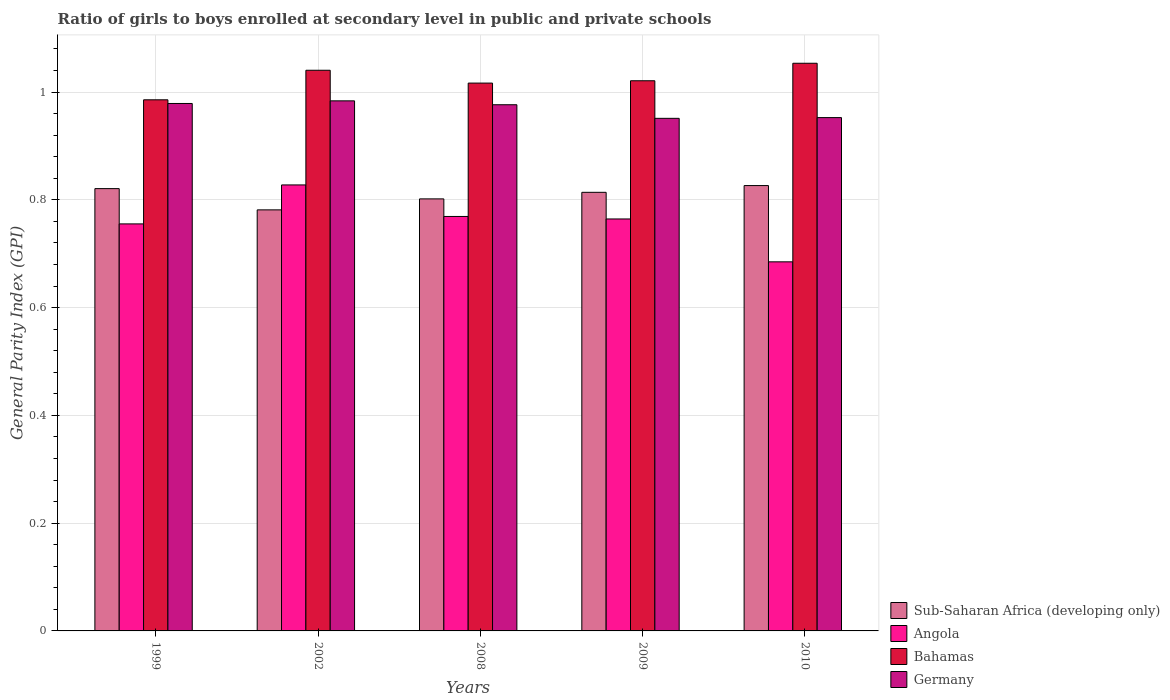Are the number of bars per tick equal to the number of legend labels?
Offer a terse response. Yes. Are the number of bars on each tick of the X-axis equal?
Your answer should be compact. Yes. How many bars are there on the 4th tick from the left?
Offer a very short reply. 4. In how many cases, is the number of bars for a given year not equal to the number of legend labels?
Provide a succinct answer. 0. What is the general parity index in Germany in 2002?
Offer a terse response. 0.98. Across all years, what is the maximum general parity index in Germany?
Your answer should be very brief. 0.98. Across all years, what is the minimum general parity index in Bahamas?
Give a very brief answer. 0.99. In which year was the general parity index in Bahamas maximum?
Your answer should be compact. 2010. In which year was the general parity index in Sub-Saharan Africa (developing only) minimum?
Give a very brief answer. 2002. What is the total general parity index in Sub-Saharan Africa (developing only) in the graph?
Provide a succinct answer. 4.04. What is the difference between the general parity index in Bahamas in 1999 and that in 2009?
Offer a terse response. -0.04. What is the difference between the general parity index in Angola in 2010 and the general parity index in Germany in 2002?
Give a very brief answer. -0.3. What is the average general parity index in Sub-Saharan Africa (developing only) per year?
Give a very brief answer. 0.81. In the year 2002, what is the difference between the general parity index in Bahamas and general parity index in Angola?
Your answer should be very brief. 0.21. What is the ratio of the general parity index in Germany in 1999 to that in 2008?
Give a very brief answer. 1. Is the general parity index in Sub-Saharan Africa (developing only) in 2002 less than that in 2009?
Your response must be concise. Yes. Is the difference between the general parity index in Bahamas in 1999 and 2002 greater than the difference between the general parity index in Angola in 1999 and 2002?
Your answer should be very brief. Yes. What is the difference between the highest and the second highest general parity index in Angola?
Offer a very short reply. 0.06. What is the difference between the highest and the lowest general parity index in Bahamas?
Offer a terse response. 0.07. In how many years, is the general parity index in Bahamas greater than the average general parity index in Bahamas taken over all years?
Make the answer very short. 2. Is the sum of the general parity index in Angola in 2008 and 2009 greater than the maximum general parity index in Sub-Saharan Africa (developing only) across all years?
Provide a short and direct response. Yes. What does the 1st bar from the left in 2002 represents?
Your answer should be very brief. Sub-Saharan Africa (developing only). What does the 2nd bar from the right in 2010 represents?
Provide a short and direct response. Bahamas. Is it the case that in every year, the sum of the general parity index in Bahamas and general parity index in Germany is greater than the general parity index in Sub-Saharan Africa (developing only)?
Give a very brief answer. Yes. How many bars are there?
Provide a succinct answer. 20. How many years are there in the graph?
Offer a very short reply. 5. What is the difference between two consecutive major ticks on the Y-axis?
Your answer should be compact. 0.2. Are the values on the major ticks of Y-axis written in scientific E-notation?
Your answer should be compact. No. Does the graph contain any zero values?
Offer a very short reply. No. Where does the legend appear in the graph?
Your answer should be compact. Bottom right. What is the title of the graph?
Provide a succinct answer. Ratio of girls to boys enrolled at secondary level in public and private schools. What is the label or title of the X-axis?
Ensure brevity in your answer.  Years. What is the label or title of the Y-axis?
Keep it short and to the point. General Parity Index (GPI). What is the General Parity Index (GPI) of Sub-Saharan Africa (developing only) in 1999?
Your response must be concise. 0.82. What is the General Parity Index (GPI) of Angola in 1999?
Keep it short and to the point. 0.76. What is the General Parity Index (GPI) in Bahamas in 1999?
Provide a succinct answer. 0.99. What is the General Parity Index (GPI) of Germany in 1999?
Give a very brief answer. 0.98. What is the General Parity Index (GPI) in Sub-Saharan Africa (developing only) in 2002?
Provide a short and direct response. 0.78. What is the General Parity Index (GPI) of Angola in 2002?
Your answer should be very brief. 0.83. What is the General Parity Index (GPI) of Bahamas in 2002?
Your answer should be very brief. 1.04. What is the General Parity Index (GPI) of Germany in 2002?
Offer a very short reply. 0.98. What is the General Parity Index (GPI) of Sub-Saharan Africa (developing only) in 2008?
Offer a terse response. 0.8. What is the General Parity Index (GPI) in Angola in 2008?
Provide a short and direct response. 0.77. What is the General Parity Index (GPI) in Bahamas in 2008?
Make the answer very short. 1.02. What is the General Parity Index (GPI) in Germany in 2008?
Provide a succinct answer. 0.98. What is the General Parity Index (GPI) in Sub-Saharan Africa (developing only) in 2009?
Provide a succinct answer. 0.81. What is the General Parity Index (GPI) of Angola in 2009?
Ensure brevity in your answer.  0.76. What is the General Parity Index (GPI) of Bahamas in 2009?
Make the answer very short. 1.02. What is the General Parity Index (GPI) in Germany in 2009?
Your answer should be very brief. 0.95. What is the General Parity Index (GPI) of Sub-Saharan Africa (developing only) in 2010?
Your response must be concise. 0.83. What is the General Parity Index (GPI) in Angola in 2010?
Offer a very short reply. 0.68. What is the General Parity Index (GPI) of Bahamas in 2010?
Offer a terse response. 1.05. What is the General Parity Index (GPI) in Germany in 2010?
Your response must be concise. 0.95. Across all years, what is the maximum General Parity Index (GPI) in Sub-Saharan Africa (developing only)?
Provide a succinct answer. 0.83. Across all years, what is the maximum General Parity Index (GPI) of Angola?
Your response must be concise. 0.83. Across all years, what is the maximum General Parity Index (GPI) of Bahamas?
Offer a terse response. 1.05. Across all years, what is the maximum General Parity Index (GPI) of Germany?
Make the answer very short. 0.98. Across all years, what is the minimum General Parity Index (GPI) of Sub-Saharan Africa (developing only)?
Offer a very short reply. 0.78. Across all years, what is the minimum General Parity Index (GPI) of Angola?
Make the answer very short. 0.68. Across all years, what is the minimum General Parity Index (GPI) in Bahamas?
Your response must be concise. 0.99. Across all years, what is the minimum General Parity Index (GPI) in Germany?
Keep it short and to the point. 0.95. What is the total General Parity Index (GPI) of Sub-Saharan Africa (developing only) in the graph?
Give a very brief answer. 4.04. What is the total General Parity Index (GPI) of Angola in the graph?
Offer a terse response. 3.8. What is the total General Parity Index (GPI) of Bahamas in the graph?
Keep it short and to the point. 5.12. What is the total General Parity Index (GPI) in Germany in the graph?
Make the answer very short. 4.84. What is the difference between the General Parity Index (GPI) of Sub-Saharan Africa (developing only) in 1999 and that in 2002?
Provide a short and direct response. 0.04. What is the difference between the General Parity Index (GPI) of Angola in 1999 and that in 2002?
Your response must be concise. -0.07. What is the difference between the General Parity Index (GPI) in Bahamas in 1999 and that in 2002?
Your answer should be compact. -0.05. What is the difference between the General Parity Index (GPI) in Germany in 1999 and that in 2002?
Ensure brevity in your answer.  -0. What is the difference between the General Parity Index (GPI) of Sub-Saharan Africa (developing only) in 1999 and that in 2008?
Give a very brief answer. 0.02. What is the difference between the General Parity Index (GPI) of Angola in 1999 and that in 2008?
Make the answer very short. -0.01. What is the difference between the General Parity Index (GPI) of Bahamas in 1999 and that in 2008?
Provide a short and direct response. -0.03. What is the difference between the General Parity Index (GPI) of Germany in 1999 and that in 2008?
Provide a short and direct response. 0. What is the difference between the General Parity Index (GPI) in Sub-Saharan Africa (developing only) in 1999 and that in 2009?
Provide a short and direct response. 0.01. What is the difference between the General Parity Index (GPI) in Angola in 1999 and that in 2009?
Keep it short and to the point. -0.01. What is the difference between the General Parity Index (GPI) in Bahamas in 1999 and that in 2009?
Ensure brevity in your answer.  -0.04. What is the difference between the General Parity Index (GPI) in Germany in 1999 and that in 2009?
Your answer should be compact. 0.03. What is the difference between the General Parity Index (GPI) of Sub-Saharan Africa (developing only) in 1999 and that in 2010?
Give a very brief answer. -0.01. What is the difference between the General Parity Index (GPI) of Angola in 1999 and that in 2010?
Offer a very short reply. 0.07. What is the difference between the General Parity Index (GPI) in Bahamas in 1999 and that in 2010?
Provide a short and direct response. -0.07. What is the difference between the General Parity Index (GPI) of Germany in 1999 and that in 2010?
Provide a short and direct response. 0.03. What is the difference between the General Parity Index (GPI) in Sub-Saharan Africa (developing only) in 2002 and that in 2008?
Offer a very short reply. -0.02. What is the difference between the General Parity Index (GPI) of Angola in 2002 and that in 2008?
Your answer should be very brief. 0.06. What is the difference between the General Parity Index (GPI) in Bahamas in 2002 and that in 2008?
Offer a terse response. 0.02. What is the difference between the General Parity Index (GPI) of Germany in 2002 and that in 2008?
Your response must be concise. 0.01. What is the difference between the General Parity Index (GPI) in Sub-Saharan Africa (developing only) in 2002 and that in 2009?
Ensure brevity in your answer.  -0.03. What is the difference between the General Parity Index (GPI) in Angola in 2002 and that in 2009?
Make the answer very short. 0.06. What is the difference between the General Parity Index (GPI) in Bahamas in 2002 and that in 2009?
Your answer should be very brief. 0.02. What is the difference between the General Parity Index (GPI) in Germany in 2002 and that in 2009?
Ensure brevity in your answer.  0.03. What is the difference between the General Parity Index (GPI) of Sub-Saharan Africa (developing only) in 2002 and that in 2010?
Your answer should be very brief. -0.05. What is the difference between the General Parity Index (GPI) of Angola in 2002 and that in 2010?
Offer a very short reply. 0.14. What is the difference between the General Parity Index (GPI) of Bahamas in 2002 and that in 2010?
Give a very brief answer. -0.01. What is the difference between the General Parity Index (GPI) in Germany in 2002 and that in 2010?
Your answer should be compact. 0.03. What is the difference between the General Parity Index (GPI) in Sub-Saharan Africa (developing only) in 2008 and that in 2009?
Make the answer very short. -0.01. What is the difference between the General Parity Index (GPI) of Angola in 2008 and that in 2009?
Your answer should be very brief. 0. What is the difference between the General Parity Index (GPI) in Bahamas in 2008 and that in 2009?
Your answer should be very brief. -0. What is the difference between the General Parity Index (GPI) of Germany in 2008 and that in 2009?
Keep it short and to the point. 0.03. What is the difference between the General Parity Index (GPI) of Sub-Saharan Africa (developing only) in 2008 and that in 2010?
Your answer should be very brief. -0.02. What is the difference between the General Parity Index (GPI) of Angola in 2008 and that in 2010?
Provide a succinct answer. 0.08. What is the difference between the General Parity Index (GPI) of Bahamas in 2008 and that in 2010?
Provide a short and direct response. -0.04. What is the difference between the General Parity Index (GPI) in Germany in 2008 and that in 2010?
Provide a short and direct response. 0.02. What is the difference between the General Parity Index (GPI) of Sub-Saharan Africa (developing only) in 2009 and that in 2010?
Give a very brief answer. -0.01. What is the difference between the General Parity Index (GPI) of Angola in 2009 and that in 2010?
Keep it short and to the point. 0.08. What is the difference between the General Parity Index (GPI) of Bahamas in 2009 and that in 2010?
Your answer should be very brief. -0.03. What is the difference between the General Parity Index (GPI) of Germany in 2009 and that in 2010?
Keep it short and to the point. -0. What is the difference between the General Parity Index (GPI) in Sub-Saharan Africa (developing only) in 1999 and the General Parity Index (GPI) in Angola in 2002?
Your answer should be very brief. -0.01. What is the difference between the General Parity Index (GPI) in Sub-Saharan Africa (developing only) in 1999 and the General Parity Index (GPI) in Bahamas in 2002?
Your response must be concise. -0.22. What is the difference between the General Parity Index (GPI) of Sub-Saharan Africa (developing only) in 1999 and the General Parity Index (GPI) of Germany in 2002?
Provide a short and direct response. -0.16. What is the difference between the General Parity Index (GPI) in Angola in 1999 and the General Parity Index (GPI) in Bahamas in 2002?
Give a very brief answer. -0.29. What is the difference between the General Parity Index (GPI) of Angola in 1999 and the General Parity Index (GPI) of Germany in 2002?
Give a very brief answer. -0.23. What is the difference between the General Parity Index (GPI) of Bahamas in 1999 and the General Parity Index (GPI) of Germany in 2002?
Provide a short and direct response. 0. What is the difference between the General Parity Index (GPI) in Sub-Saharan Africa (developing only) in 1999 and the General Parity Index (GPI) in Angola in 2008?
Give a very brief answer. 0.05. What is the difference between the General Parity Index (GPI) in Sub-Saharan Africa (developing only) in 1999 and the General Parity Index (GPI) in Bahamas in 2008?
Provide a short and direct response. -0.2. What is the difference between the General Parity Index (GPI) in Sub-Saharan Africa (developing only) in 1999 and the General Parity Index (GPI) in Germany in 2008?
Your answer should be compact. -0.16. What is the difference between the General Parity Index (GPI) in Angola in 1999 and the General Parity Index (GPI) in Bahamas in 2008?
Ensure brevity in your answer.  -0.26. What is the difference between the General Parity Index (GPI) in Angola in 1999 and the General Parity Index (GPI) in Germany in 2008?
Keep it short and to the point. -0.22. What is the difference between the General Parity Index (GPI) in Bahamas in 1999 and the General Parity Index (GPI) in Germany in 2008?
Offer a terse response. 0.01. What is the difference between the General Parity Index (GPI) in Sub-Saharan Africa (developing only) in 1999 and the General Parity Index (GPI) in Angola in 2009?
Ensure brevity in your answer.  0.06. What is the difference between the General Parity Index (GPI) of Sub-Saharan Africa (developing only) in 1999 and the General Parity Index (GPI) of Bahamas in 2009?
Give a very brief answer. -0.2. What is the difference between the General Parity Index (GPI) of Sub-Saharan Africa (developing only) in 1999 and the General Parity Index (GPI) of Germany in 2009?
Offer a very short reply. -0.13. What is the difference between the General Parity Index (GPI) of Angola in 1999 and the General Parity Index (GPI) of Bahamas in 2009?
Your response must be concise. -0.27. What is the difference between the General Parity Index (GPI) in Angola in 1999 and the General Parity Index (GPI) in Germany in 2009?
Keep it short and to the point. -0.2. What is the difference between the General Parity Index (GPI) in Bahamas in 1999 and the General Parity Index (GPI) in Germany in 2009?
Give a very brief answer. 0.03. What is the difference between the General Parity Index (GPI) in Sub-Saharan Africa (developing only) in 1999 and the General Parity Index (GPI) in Angola in 2010?
Make the answer very short. 0.14. What is the difference between the General Parity Index (GPI) of Sub-Saharan Africa (developing only) in 1999 and the General Parity Index (GPI) of Bahamas in 2010?
Offer a very short reply. -0.23. What is the difference between the General Parity Index (GPI) in Sub-Saharan Africa (developing only) in 1999 and the General Parity Index (GPI) in Germany in 2010?
Give a very brief answer. -0.13. What is the difference between the General Parity Index (GPI) of Angola in 1999 and the General Parity Index (GPI) of Bahamas in 2010?
Your answer should be very brief. -0.3. What is the difference between the General Parity Index (GPI) of Angola in 1999 and the General Parity Index (GPI) of Germany in 2010?
Provide a succinct answer. -0.2. What is the difference between the General Parity Index (GPI) of Bahamas in 1999 and the General Parity Index (GPI) of Germany in 2010?
Ensure brevity in your answer.  0.03. What is the difference between the General Parity Index (GPI) of Sub-Saharan Africa (developing only) in 2002 and the General Parity Index (GPI) of Angola in 2008?
Ensure brevity in your answer.  0.01. What is the difference between the General Parity Index (GPI) of Sub-Saharan Africa (developing only) in 2002 and the General Parity Index (GPI) of Bahamas in 2008?
Give a very brief answer. -0.24. What is the difference between the General Parity Index (GPI) in Sub-Saharan Africa (developing only) in 2002 and the General Parity Index (GPI) in Germany in 2008?
Give a very brief answer. -0.2. What is the difference between the General Parity Index (GPI) of Angola in 2002 and the General Parity Index (GPI) of Bahamas in 2008?
Provide a short and direct response. -0.19. What is the difference between the General Parity Index (GPI) of Angola in 2002 and the General Parity Index (GPI) of Germany in 2008?
Your answer should be very brief. -0.15. What is the difference between the General Parity Index (GPI) in Bahamas in 2002 and the General Parity Index (GPI) in Germany in 2008?
Give a very brief answer. 0.06. What is the difference between the General Parity Index (GPI) in Sub-Saharan Africa (developing only) in 2002 and the General Parity Index (GPI) in Angola in 2009?
Your answer should be compact. 0.02. What is the difference between the General Parity Index (GPI) in Sub-Saharan Africa (developing only) in 2002 and the General Parity Index (GPI) in Bahamas in 2009?
Make the answer very short. -0.24. What is the difference between the General Parity Index (GPI) in Sub-Saharan Africa (developing only) in 2002 and the General Parity Index (GPI) in Germany in 2009?
Keep it short and to the point. -0.17. What is the difference between the General Parity Index (GPI) in Angola in 2002 and the General Parity Index (GPI) in Bahamas in 2009?
Your response must be concise. -0.19. What is the difference between the General Parity Index (GPI) in Angola in 2002 and the General Parity Index (GPI) in Germany in 2009?
Offer a terse response. -0.12. What is the difference between the General Parity Index (GPI) in Bahamas in 2002 and the General Parity Index (GPI) in Germany in 2009?
Give a very brief answer. 0.09. What is the difference between the General Parity Index (GPI) in Sub-Saharan Africa (developing only) in 2002 and the General Parity Index (GPI) in Angola in 2010?
Offer a very short reply. 0.1. What is the difference between the General Parity Index (GPI) of Sub-Saharan Africa (developing only) in 2002 and the General Parity Index (GPI) of Bahamas in 2010?
Offer a terse response. -0.27. What is the difference between the General Parity Index (GPI) of Sub-Saharan Africa (developing only) in 2002 and the General Parity Index (GPI) of Germany in 2010?
Make the answer very short. -0.17. What is the difference between the General Parity Index (GPI) in Angola in 2002 and the General Parity Index (GPI) in Bahamas in 2010?
Ensure brevity in your answer.  -0.23. What is the difference between the General Parity Index (GPI) in Angola in 2002 and the General Parity Index (GPI) in Germany in 2010?
Keep it short and to the point. -0.12. What is the difference between the General Parity Index (GPI) in Bahamas in 2002 and the General Parity Index (GPI) in Germany in 2010?
Your answer should be very brief. 0.09. What is the difference between the General Parity Index (GPI) of Sub-Saharan Africa (developing only) in 2008 and the General Parity Index (GPI) of Angola in 2009?
Offer a terse response. 0.04. What is the difference between the General Parity Index (GPI) of Sub-Saharan Africa (developing only) in 2008 and the General Parity Index (GPI) of Bahamas in 2009?
Provide a short and direct response. -0.22. What is the difference between the General Parity Index (GPI) of Sub-Saharan Africa (developing only) in 2008 and the General Parity Index (GPI) of Germany in 2009?
Your answer should be very brief. -0.15. What is the difference between the General Parity Index (GPI) of Angola in 2008 and the General Parity Index (GPI) of Bahamas in 2009?
Give a very brief answer. -0.25. What is the difference between the General Parity Index (GPI) of Angola in 2008 and the General Parity Index (GPI) of Germany in 2009?
Your answer should be very brief. -0.18. What is the difference between the General Parity Index (GPI) of Bahamas in 2008 and the General Parity Index (GPI) of Germany in 2009?
Your response must be concise. 0.07. What is the difference between the General Parity Index (GPI) of Sub-Saharan Africa (developing only) in 2008 and the General Parity Index (GPI) of Angola in 2010?
Ensure brevity in your answer.  0.12. What is the difference between the General Parity Index (GPI) of Sub-Saharan Africa (developing only) in 2008 and the General Parity Index (GPI) of Bahamas in 2010?
Your response must be concise. -0.25. What is the difference between the General Parity Index (GPI) in Sub-Saharan Africa (developing only) in 2008 and the General Parity Index (GPI) in Germany in 2010?
Offer a terse response. -0.15. What is the difference between the General Parity Index (GPI) of Angola in 2008 and the General Parity Index (GPI) of Bahamas in 2010?
Your answer should be compact. -0.28. What is the difference between the General Parity Index (GPI) of Angola in 2008 and the General Parity Index (GPI) of Germany in 2010?
Offer a very short reply. -0.18. What is the difference between the General Parity Index (GPI) in Bahamas in 2008 and the General Parity Index (GPI) in Germany in 2010?
Provide a short and direct response. 0.06. What is the difference between the General Parity Index (GPI) of Sub-Saharan Africa (developing only) in 2009 and the General Parity Index (GPI) of Angola in 2010?
Your answer should be compact. 0.13. What is the difference between the General Parity Index (GPI) in Sub-Saharan Africa (developing only) in 2009 and the General Parity Index (GPI) in Bahamas in 2010?
Make the answer very short. -0.24. What is the difference between the General Parity Index (GPI) of Sub-Saharan Africa (developing only) in 2009 and the General Parity Index (GPI) of Germany in 2010?
Your response must be concise. -0.14. What is the difference between the General Parity Index (GPI) of Angola in 2009 and the General Parity Index (GPI) of Bahamas in 2010?
Provide a succinct answer. -0.29. What is the difference between the General Parity Index (GPI) in Angola in 2009 and the General Parity Index (GPI) in Germany in 2010?
Your answer should be compact. -0.19. What is the difference between the General Parity Index (GPI) in Bahamas in 2009 and the General Parity Index (GPI) in Germany in 2010?
Your response must be concise. 0.07. What is the average General Parity Index (GPI) in Sub-Saharan Africa (developing only) per year?
Give a very brief answer. 0.81. What is the average General Parity Index (GPI) in Angola per year?
Offer a terse response. 0.76. What is the average General Parity Index (GPI) of Bahamas per year?
Offer a terse response. 1.02. What is the average General Parity Index (GPI) of Germany per year?
Offer a terse response. 0.97. In the year 1999, what is the difference between the General Parity Index (GPI) of Sub-Saharan Africa (developing only) and General Parity Index (GPI) of Angola?
Provide a succinct answer. 0.07. In the year 1999, what is the difference between the General Parity Index (GPI) of Sub-Saharan Africa (developing only) and General Parity Index (GPI) of Bahamas?
Give a very brief answer. -0.16. In the year 1999, what is the difference between the General Parity Index (GPI) in Sub-Saharan Africa (developing only) and General Parity Index (GPI) in Germany?
Your response must be concise. -0.16. In the year 1999, what is the difference between the General Parity Index (GPI) in Angola and General Parity Index (GPI) in Bahamas?
Provide a short and direct response. -0.23. In the year 1999, what is the difference between the General Parity Index (GPI) of Angola and General Parity Index (GPI) of Germany?
Offer a terse response. -0.22. In the year 1999, what is the difference between the General Parity Index (GPI) of Bahamas and General Parity Index (GPI) of Germany?
Your answer should be compact. 0.01. In the year 2002, what is the difference between the General Parity Index (GPI) in Sub-Saharan Africa (developing only) and General Parity Index (GPI) in Angola?
Make the answer very short. -0.05. In the year 2002, what is the difference between the General Parity Index (GPI) of Sub-Saharan Africa (developing only) and General Parity Index (GPI) of Bahamas?
Your answer should be very brief. -0.26. In the year 2002, what is the difference between the General Parity Index (GPI) of Sub-Saharan Africa (developing only) and General Parity Index (GPI) of Germany?
Ensure brevity in your answer.  -0.2. In the year 2002, what is the difference between the General Parity Index (GPI) in Angola and General Parity Index (GPI) in Bahamas?
Your answer should be compact. -0.21. In the year 2002, what is the difference between the General Parity Index (GPI) of Angola and General Parity Index (GPI) of Germany?
Provide a short and direct response. -0.16. In the year 2002, what is the difference between the General Parity Index (GPI) of Bahamas and General Parity Index (GPI) of Germany?
Provide a short and direct response. 0.06. In the year 2008, what is the difference between the General Parity Index (GPI) of Sub-Saharan Africa (developing only) and General Parity Index (GPI) of Angola?
Provide a succinct answer. 0.03. In the year 2008, what is the difference between the General Parity Index (GPI) of Sub-Saharan Africa (developing only) and General Parity Index (GPI) of Bahamas?
Give a very brief answer. -0.21. In the year 2008, what is the difference between the General Parity Index (GPI) in Sub-Saharan Africa (developing only) and General Parity Index (GPI) in Germany?
Provide a short and direct response. -0.17. In the year 2008, what is the difference between the General Parity Index (GPI) in Angola and General Parity Index (GPI) in Bahamas?
Give a very brief answer. -0.25. In the year 2008, what is the difference between the General Parity Index (GPI) of Angola and General Parity Index (GPI) of Germany?
Offer a terse response. -0.21. In the year 2008, what is the difference between the General Parity Index (GPI) in Bahamas and General Parity Index (GPI) in Germany?
Your response must be concise. 0.04. In the year 2009, what is the difference between the General Parity Index (GPI) in Sub-Saharan Africa (developing only) and General Parity Index (GPI) in Angola?
Give a very brief answer. 0.05. In the year 2009, what is the difference between the General Parity Index (GPI) of Sub-Saharan Africa (developing only) and General Parity Index (GPI) of Bahamas?
Provide a short and direct response. -0.21. In the year 2009, what is the difference between the General Parity Index (GPI) of Sub-Saharan Africa (developing only) and General Parity Index (GPI) of Germany?
Offer a very short reply. -0.14. In the year 2009, what is the difference between the General Parity Index (GPI) of Angola and General Parity Index (GPI) of Bahamas?
Make the answer very short. -0.26. In the year 2009, what is the difference between the General Parity Index (GPI) in Angola and General Parity Index (GPI) in Germany?
Your answer should be compact. -0.19. In the year 2009, what is the difference between the General Parity Index (GPI) of Bahamas and General Parity Index (GPI) of Germany?
Your answer should be compact. 0.07. In the year 2010, what is the difference between the General Parity Index (GPI) of Sub-Saharan Africa (developing only) and General Parity Index (GPI) of Angola?
Provide a short and direct response. 0.14. In the year 2010, what is the difference between the General Parity Index (GPI) in Sub-Saharan Africa (developing only) and General Parity Index (GPI) in Bahamas?
Your response must be concise. -0.23. In the year 2010, what is the difference between the General Parity Index (GPI) of Sub-Saharan Africa (developing only) and General Parity Index (GPI) of Germany?
Provide a short and direct response. -0.13. In the year 2010, what is the difference between the General Parity Index (GPI) of Angola and General Parity Index (GPI) of Bahamas?
Provide a short and direct response. -0.37. In the year 2010, what is the difference between the General Parity Index (GPI) of Angola and General Parity Index (GPI) of Germany?
Ensure brevity in your answer.  -0.27. In the year 2010, what is the difference between the General Parity Index (GPI) of Bahamas and General Parity Index (GPI) of Germany?
Provide a short and direct response. 0.1. What is the ratio of the General Parity Index (GPI) of Sub-Saharan Africa (developing only) in 1999 to that in 2002?
Keep it short and to the point. 1.05. What is the ratio of the General Parity Index (GPI) of Angola in 1999 to that in 2002?
Keep it short and to the point. 0.91. What is the ratio of the General Parity Index (GPI) of Bahamas in 1999 to that in 2002?
Give a very brief answer. 0.95. What is the ratio of the General Parity Index (GPI) of Germany in 1999 to that in 2002?
Offer a very short reply. 1. What is the ratio of the General Parity Index (GPI) in Sub-Saharan Africa (developing only) in 1999 to that in 2008?
Your answer should be very brief. 1.02. What is the ratio of the General Parity Index (GPI) of Bahamas in 1999 to that in 2008?
Your answer should be compact. 0.97. What is the ratio of the General Parity Index (GPI) of Sub-Saharan Africa (developing only) in 1999 to that in 2009?
Provide a short and direct response. 1.01. What is the ratio of the General Parity Index (GPI) of Angola in 1999 to that in 2009?
Your answer should be very brief. 0.99. What is the ratio of the General Parity Index (GPI) of Bahamas in 1999 to that in 2009?
Offer a very short reply. 0.97. What is the ratio of the General Parity Index (GPI) of Germany in 1999 to that in 2009?
Your answer should be compact. 1.03. What is the ratio of the General Parity Index (GPI) of Angola in 1999 to that in 2010?
Keep it short and to the point. 1.1. What is the ratio of the General Parity Index (GPI) in Bahamas in 1999 to that in 2010?
Offer a terse response. 0.94. What is the ratio of the General Parity Index (GPI) of Germany in 1999 to that in 2010?
Give a very brief answer. 1.03. What is the ratio of the General Parity Index (GPI) of Sub-Saharan Africa (developing only) in 2002 to that in 2008?
Your answer should be compact. 0.97. What is the ratio of the General Parity Index (GPI) in Angola in 2002 to that in 2008?
Offer a very short reply. 1.08. What is the ratio of the General Parity Index (GPI) of Bahamas in 2002 to that in 2008?
Keep it short and to the point. 1.02. What is the ratio of the General Parity Index (GPI) in Germany in 2002 to that in 2008?
Ensure brevity in your answer.  1.01. What is the ratio of the General Parity Index (GPI) in Sub-Saharan Africa (developing only) in 2002 to that in 2009?
Your answer should be very brief. 0.96. What is the ratio of the General Parity Index (GPI) of Angola in 2002 to that in 2009?
Your response must be concise. 1.08. What is the ratio of the General Parity Index (GPI) of Bahamas in 2002 to that in 2009?
Your answer should be very brief. 1.02. What is the ratio of the General Parity Index (GPI) in Germany in 2002 to that in 2009?
Ensure brevity in your answer.  1.03. What is the ratio of the General Parity Index (GPI) of Sub-Saharan Africa (developing only) in 2002 to that in 2010?
Give a very brief answer. 0.95. What is the ratio of the General Parity Index (GPI) of Angola in 2002 to that in 2010?
Provide a succinct answer. 1.21. What is the ratio of the General Parity Index (GPI) of Bahamas in 2002 to that in 2010?
Provide a succinct answer. 0.99. What is the ratio of the General Parity Index (GPI) in Germany in 2002 to that in 2010?
Offer a very short reply. 1.03. What is the ratio of the General Parity Index (GPI) of Sub-Saharan Africa (developing only) in 2008 to that in 2009?
Give a very brief answer. 0.98. What is the ratio of the General Parity Index (GPI) in Angola in 2008 to that in 2009?
Ensure brevity in your answer.  1.01. What is the ratio of the General Parity Index (GPI) in Germany in 2008 to that in 2009?
Offer a very short reply. 1.03. What is the ratio of the General Parity Index (GPI) in Sub-Saharan Africa (developing only) in 2008 to that in 2010?
Offer a very short reply. 0.97. What is the ratio of the General Parity Index (GPI) in Angola in 2008 to that in 2010?
Give a very brief answer. 1.12. What is the ratio of the General Parity Index (GPI) in Bahamas in 2008 to that in 2010?
Offer a very short reply. 0.97. What is the ratio of the General Parity Index (GPI) of Germany in 2008 to that in 2010?
Your answer should be very brief. 1.03. What is the ratio of the General Parity Index (GPI) of Sub-Saharan Africa (developing only) in 2009 to that in 2010?
Provide a succinct answer. 0.98. What is the ratio of the General Parity Index (GPI) in Angola in 2009 to that in 2010?
Give a very brief answer. 1.12. What is the ratio of the General Parity Index (GPI) of Bahamas in 2009 to that in 2010?
Offer a terse response. 0.97. What is the ratio of the General Parity Index (GPI) of Germany in 2009 to that in 2010?
Your response must be concise. 1. What is the difference between the highest and the second highest General Parity Index (GPI) of Sub-Saharan Africa (developing only)?
Keep it short and to the point. 0.01. What is the difference between the highest and the second highest General Parity Index (GPI) of Angola?
Provide a short and direct response. 0.06. What is the difference between the highest and the second highest General Parity Index (GPI) of Bahamas?
Ensure brevity in your answer.  0.01. What is the difference between the highest and the second highest General Parity Index (GPI) in Germany?
Your answer should be very brief. 0. What is the difference between the highest and the lowest General Parity Index (GPI) in Sub-Saharan Africa (developing only)?
Your response must be concise. 0.05. What is the difference between the highest and the lowest General Parity Index (GPI) in Angola?
Give a very brief answer. 0.14. What is the difference between the highest and the lowest General Parity Index (GPI) of Bahamas?
Your answer should be very brief. 0.07. What is the difference between the highest and the lowest General Parity Index (GPI) of Germany?
Make the answer very short. 0.03. 